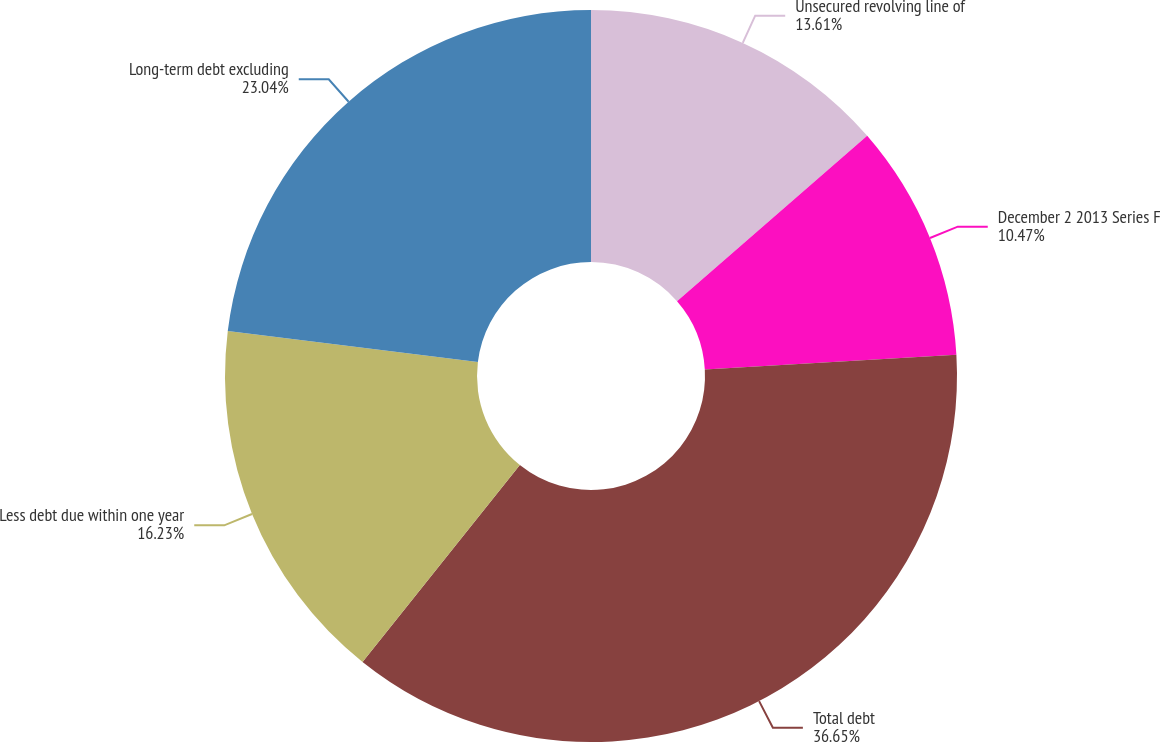Convert chart to OTSL. <chart><loc_0><loc_0><loc_500><loc_500><pie_chart><fcel>Unsecured revolving line of<fcel>December 2 2013 Series F<fcel>Total debt<fcel>Less debt due within one year<fcel>Long-term debt excluding<nl><fcel>13.61%<fcel>10.47%<fcel>36.65%<fcel>16.23%<fcel>23.04%<nl></chart> 